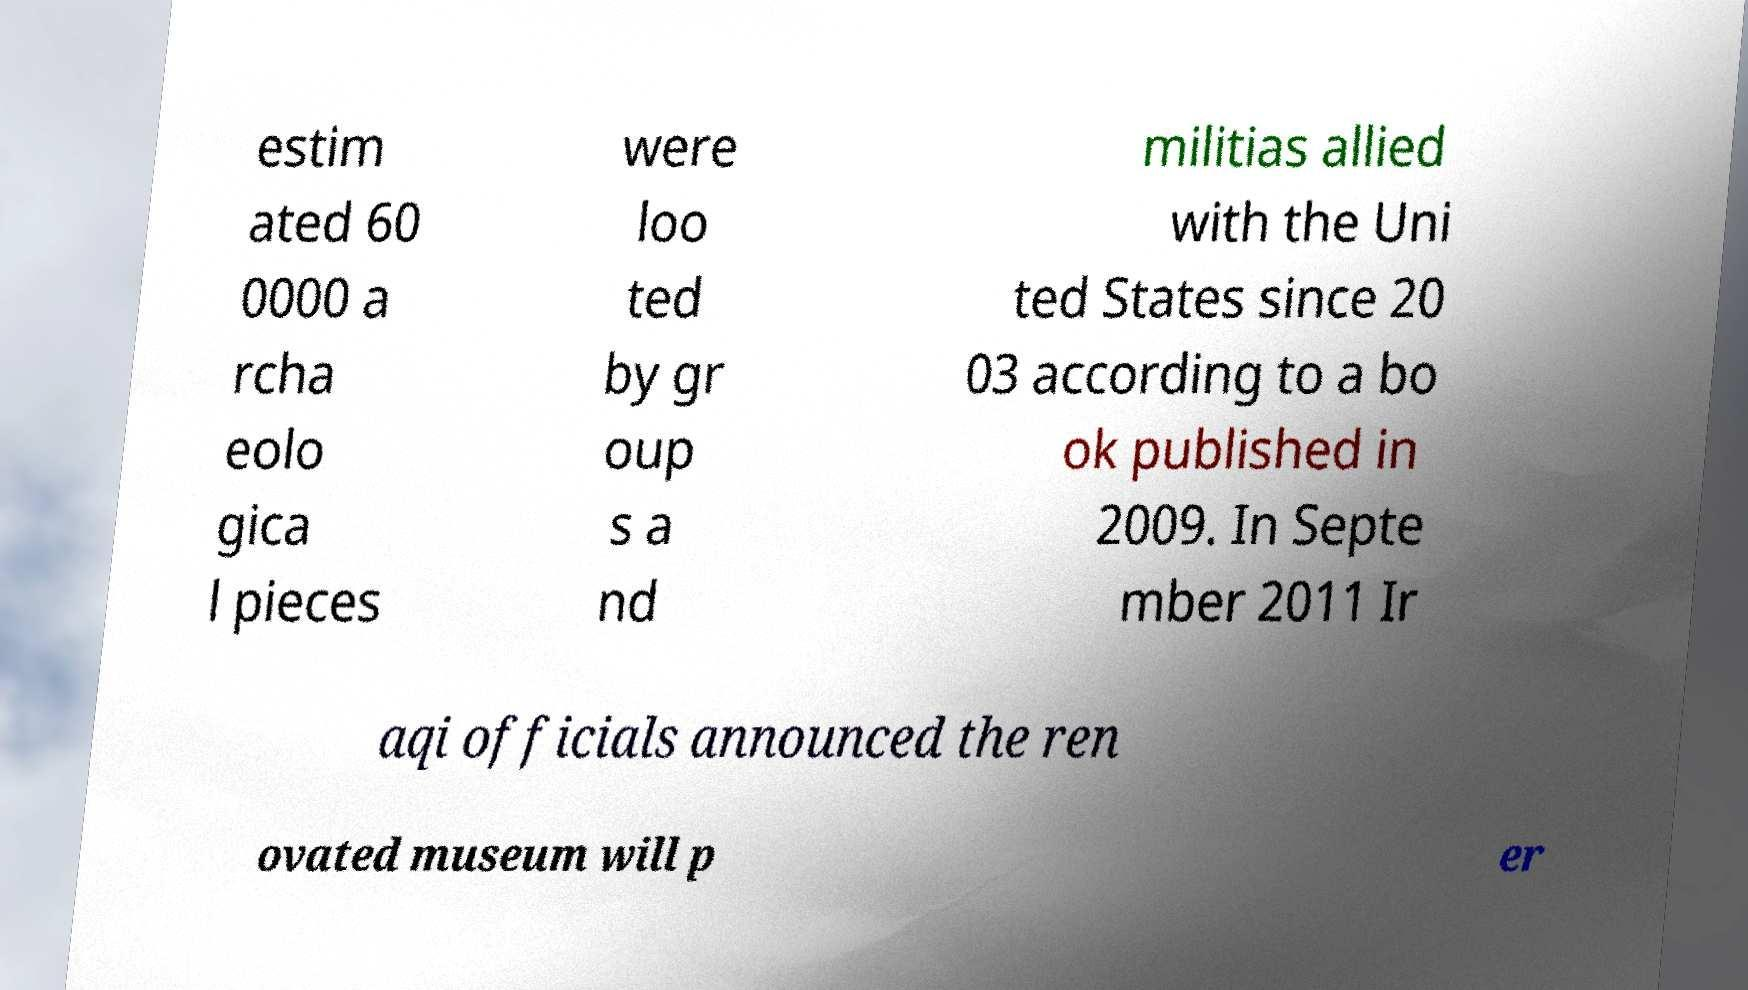Could you assist in decoding the text presented in this image and type it out clearly? estim ated 60 0000 a rcha eolo gica l pieces were loo ted by gr oup s a nd militias allied with the Uni ted States since 20 03 according to a bo ok published in 2009. In Septe mber 2011 Ir aqi officials announced the ren ovated museum will p er 